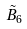Convert formula to latex. <formula><loc_0><loc_0><loc_500><loc_500>\tilde { B } _ { 6 }</formula> 